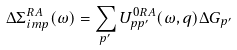<formula> <loc_0><loc_0><loc_500><loc_500>\Delta \Sigma ^ { R A } _ { i m p } ( \omega ) = \sum _ { p ^ { \prime } } U ^ { 0 R A } _ { p p ^ { \prime } } ( \omega , { q } ) \Delta G _ { p ^ { \prime } }</formula> 